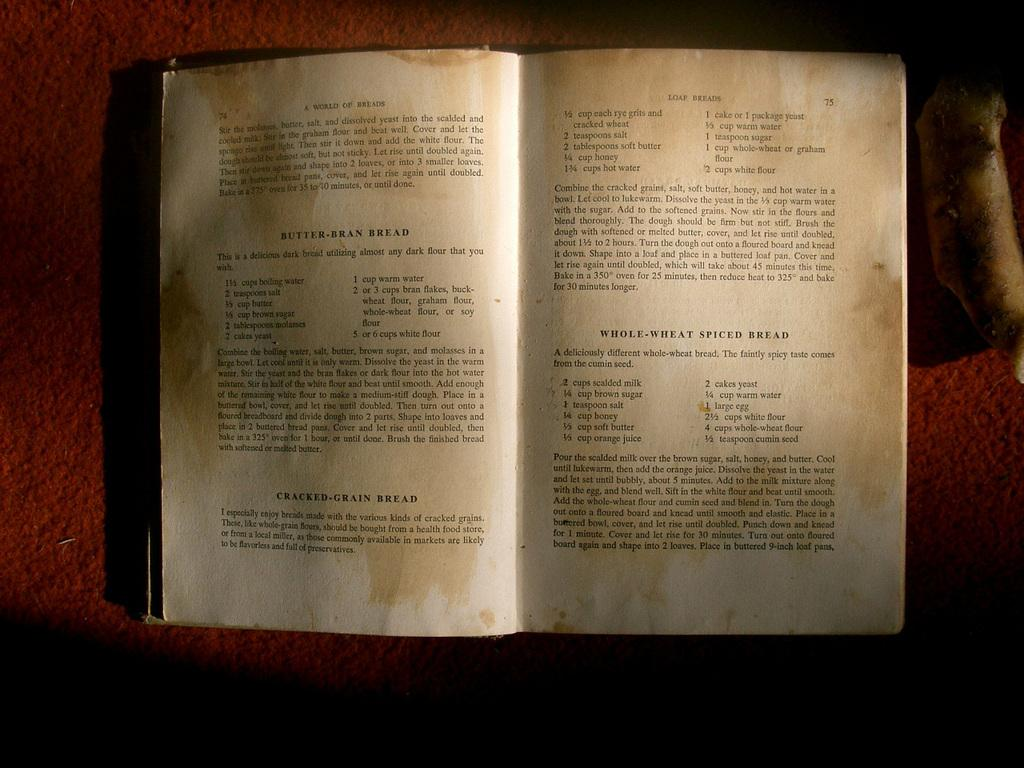Provide a one-sentence caption for the provided image. The book A World of Breads is open to pages showing recipes for Butter Bran Bread and Loaf Breads. 